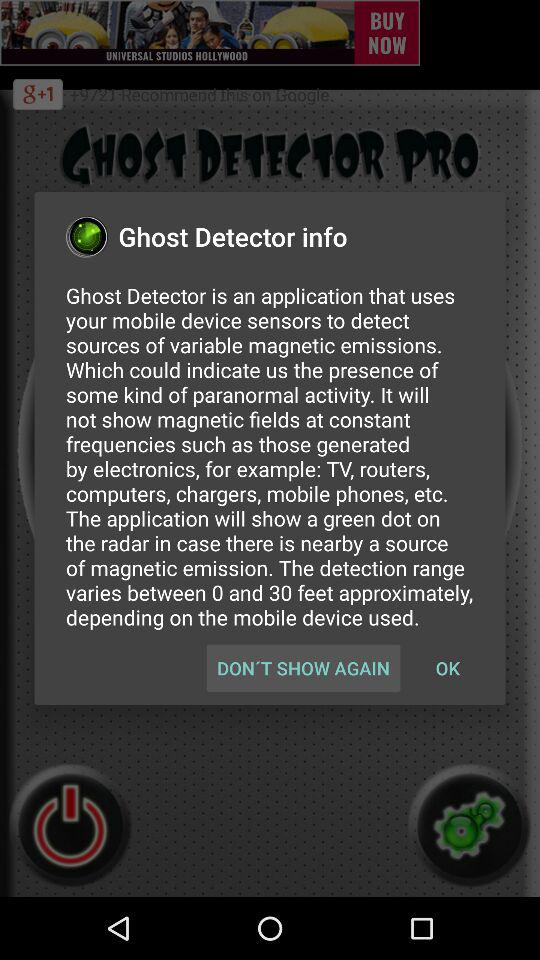What is the name of the application? The names of the applications are "GHOST DETECTOR PRO" and "Ghost Detector". 